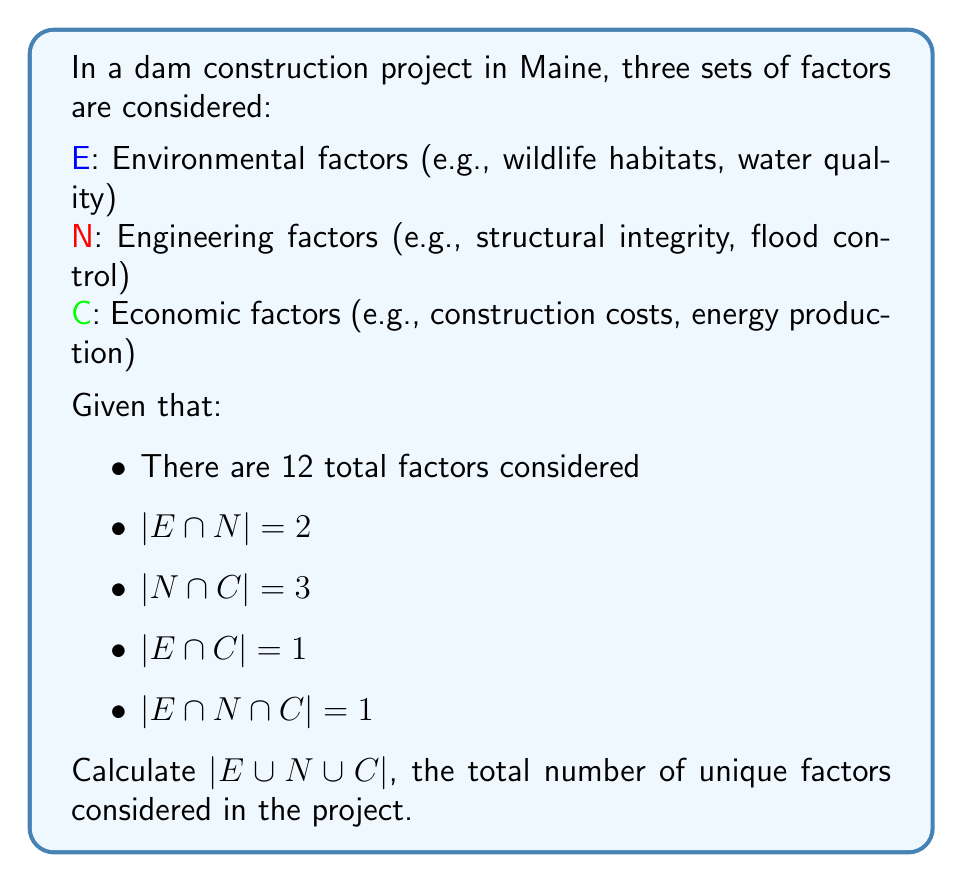Can you solve this math problem? To solve this problem, we'll use the Inclusion-Exclusion Principle for three sets:

$$|E \cup N \cup C| = |E| + |N| + |C| - |E \cap N| - |N \cap C| - |E \cap C| + |E \cap N \cap C|$$

We're given $|E \cap N|$, $|N \cap C|$, $|E \cap C|$, and $|E \cap N \cap C|$, but we need to find $|E|$, $|N|$, and $|C|$.

Let's use Venn diagrams to visualize and calculate:

[asy]
unitsize(1cm);
pair A = (0,0), B = (2,0), C = (1,1.7);
path c1 = circle(A,1.2);
path c2 = circle(B,1.2);
path c3 = circle(C,1.2);
fill(c1,rgb(0.9,0.9,1));
fill(c2,rgb(0.9,1,0.9));
fill(c3,rgb(1,0.9,0.9));
draw(c1);
draw(c2);
draw(c3);
label("E",A+(-0.8,-0.8));
label("N",B+(0.8,-0.8));
label("C",C+(0,1));
label("1",A+(0.4,0.4));
label("1",B+(-0.4,0.4));
label("2",C+(0,-0.4));
label("a",(A+B)/2);
label("b",A+(-0.4,0.4));
label("c",B+(0.4,0.4));
[/asy]

Let $a = |E \cap N| - |E \cap N \cap C| = 2 - 1 = 1$
Let $b = |E \cap C| - |E \cap N \cap C| = 1 - 1 = 0$
Let $c = |N \cap C| - |E \cap N \cap C| = 3 - 1 = 2$

Now we can calculate:
$|E| = 1 + a + b + |E \cap N \cap C| = 1 + 1 + 0 + 1 = 3$
$|N| = 1 + a + c + |E \cap N \cap C| = 1 + 1 + 2 + 1 = 5$
$|C| = 2 + b + c + |E \cap N \cap C| = 2 + 0 + 2 + 1 = 5$

Substituting these values into the Inclusion-Exclusion Principle:

$$|E \cup N \cup C| = 3 + 5 + 5 - 2 - 3 - 1 + 1 = 8$$
Answer: $|E \cup N \cup C| = 8$ 